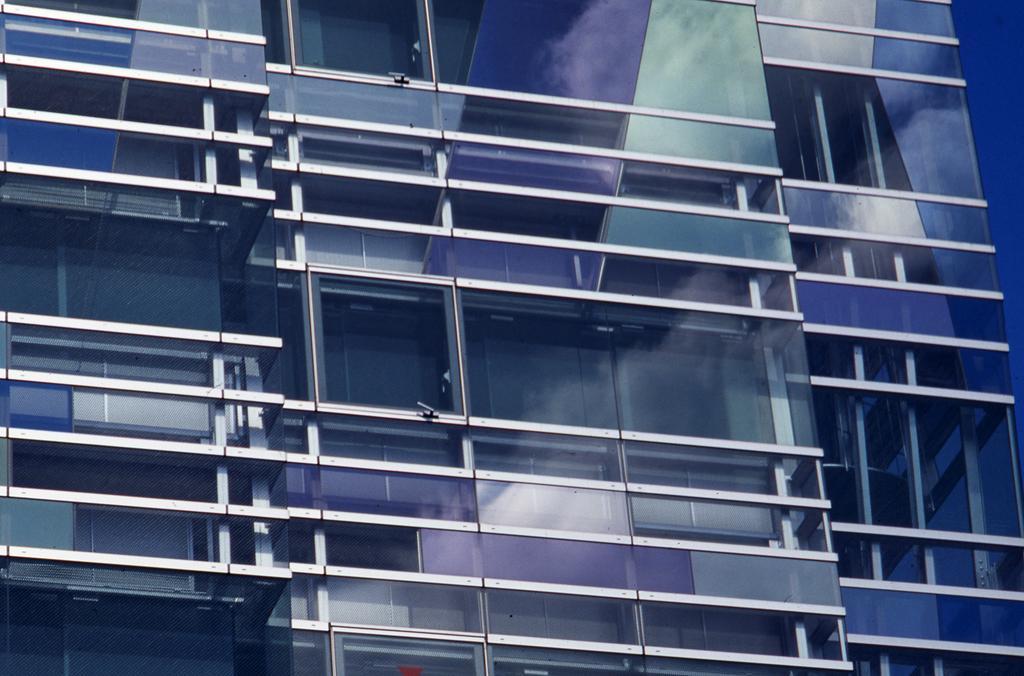Could you give a brief overview of what you see in this image? In this picture we can see a building. 